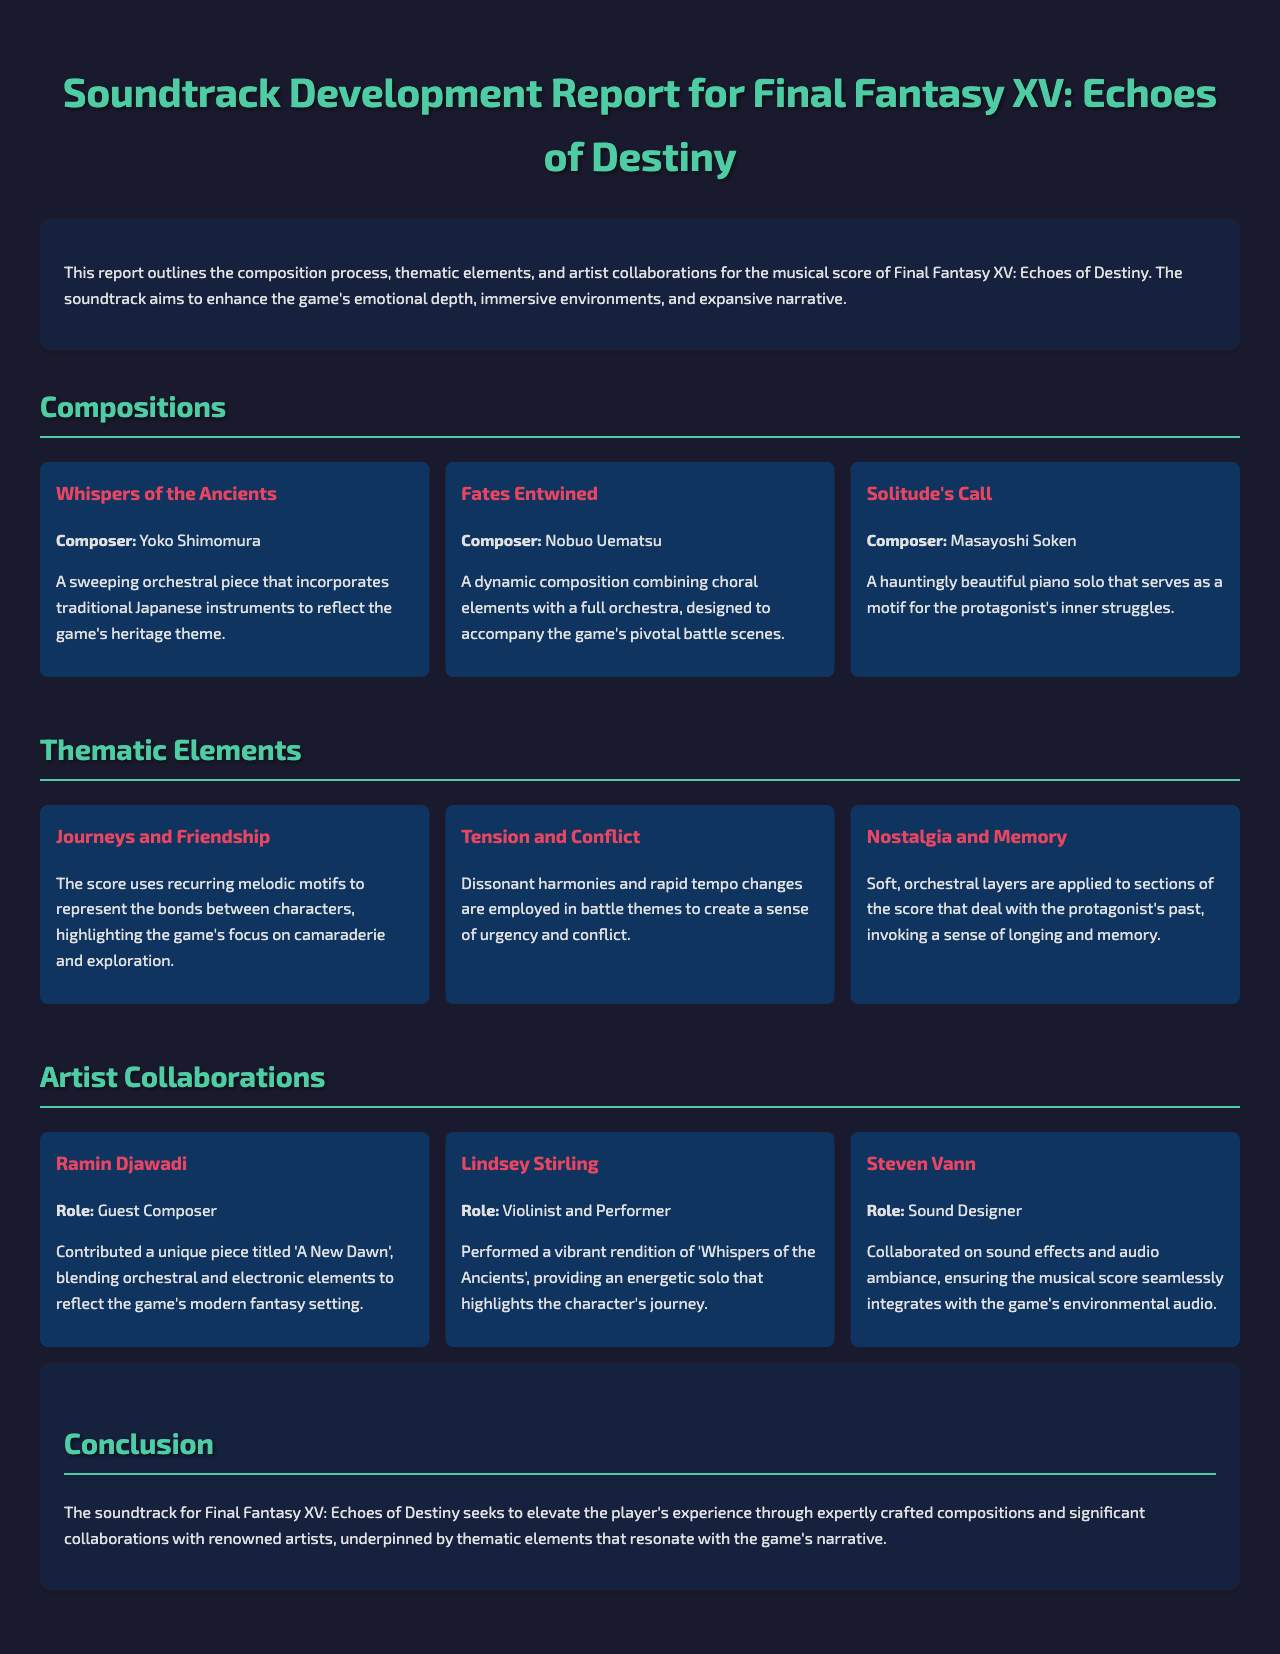What is the title of the report? The title of the report is presented at the top of the document.
Answer: Soundtrack Development Report for Final Fantasy XV: Echoes of Destiny Who composed "Fates Entwined"? The composer's name is provided alongside the composition title.
Answer: Nobuo Uematsu What musical element does "Solitude's Call" primarily feature? The description of "Solitude's Call" indicates its main instrument.
Answer: Piano solo What thematic element is represented by "Journeys and Friendship"? The document explains the thematic focus of this element in the score.
Answer: Bonds between characters Who is the guest composer mentioned in the artist collaborations? The report identifies a specific role for Ramin Djawadi.
Answer: Ramin Djawadi Which composition highlights the protagonist's inner struggles? The report specifies the focus of "Solitude's Call".
Answer: Solitude's Call How does the score invoke a sense of nostalgia? The document details the elements used in sections dealing with the protagonist's past.
Answer: Soft, orchestral layers What role did Steven Vann play in the development? The report defines the contribution of Steven Vann in the project.
Answer: Sound Designer 